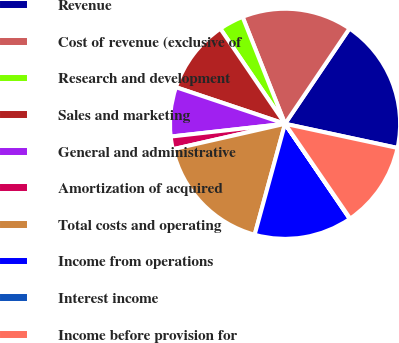<chart> <loc_0><loc_0><loc_500><loc_500><pie_chart><fcel>Revenue<fcel>Cost of revenue (exclusive of<fcel>Research and development<fcel>Sales and marketing<fcel>General and administrative<fcel>Amortization of acquired<fcel>Total costs and operating<fcel>Income from operations<fcel>Interest income<fcel>Income before provision for<nl><fcel>18.9%<fcel>15.48%<fcel>3.49%<fcel>10.34%<fcel>6.92%<fcel>1.78%<fcel>17.19%<fcel>13.77%<fcel>0.07%<fcel>12.05%<nl></chart> 